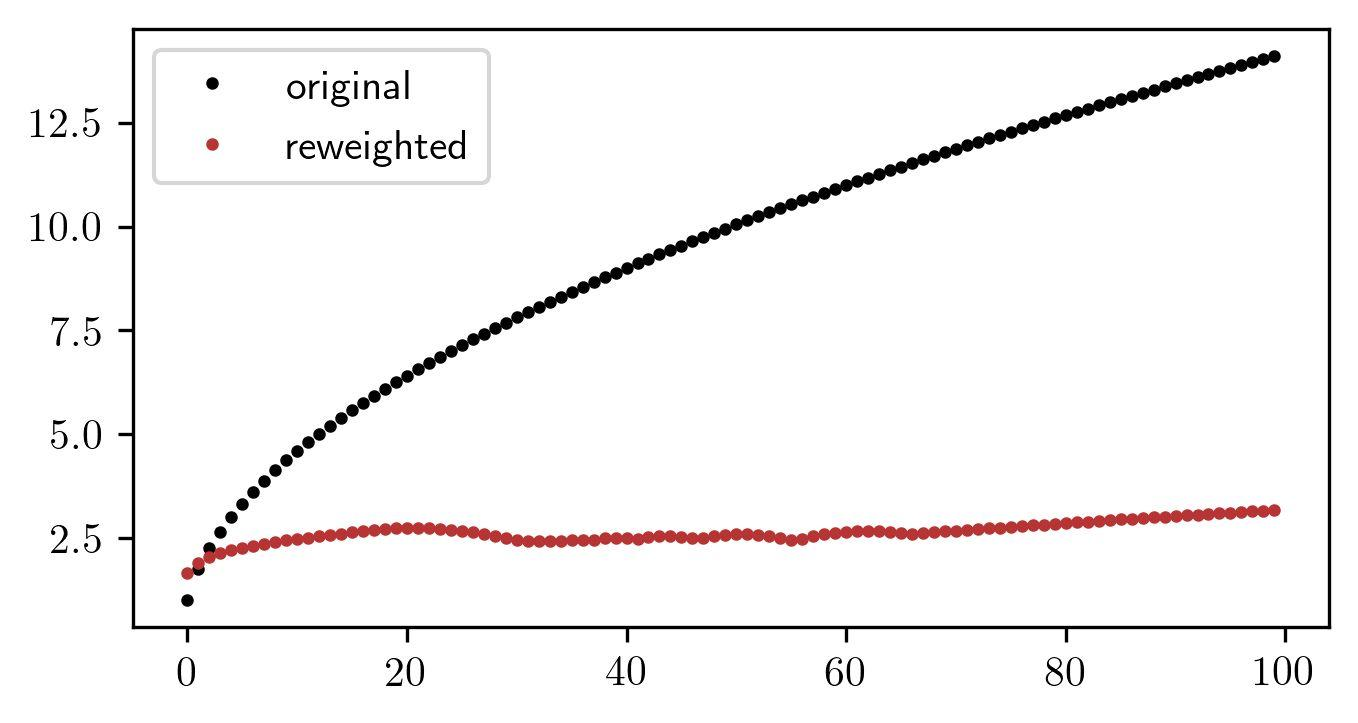Based on the graph, what is the approximate range of values for the reweighted data points? A. 0 to 2.5 B. 2.5 to 5.0 C. 0 to 10.0 D. 0 to 12.5 The 'reweighted' data points, marked in red, lie within the lower band of the y-axis, which ranges from 0 to approximately 2.5, as they do not rise above this value on the graph. Therefore, the correct answer is A. 